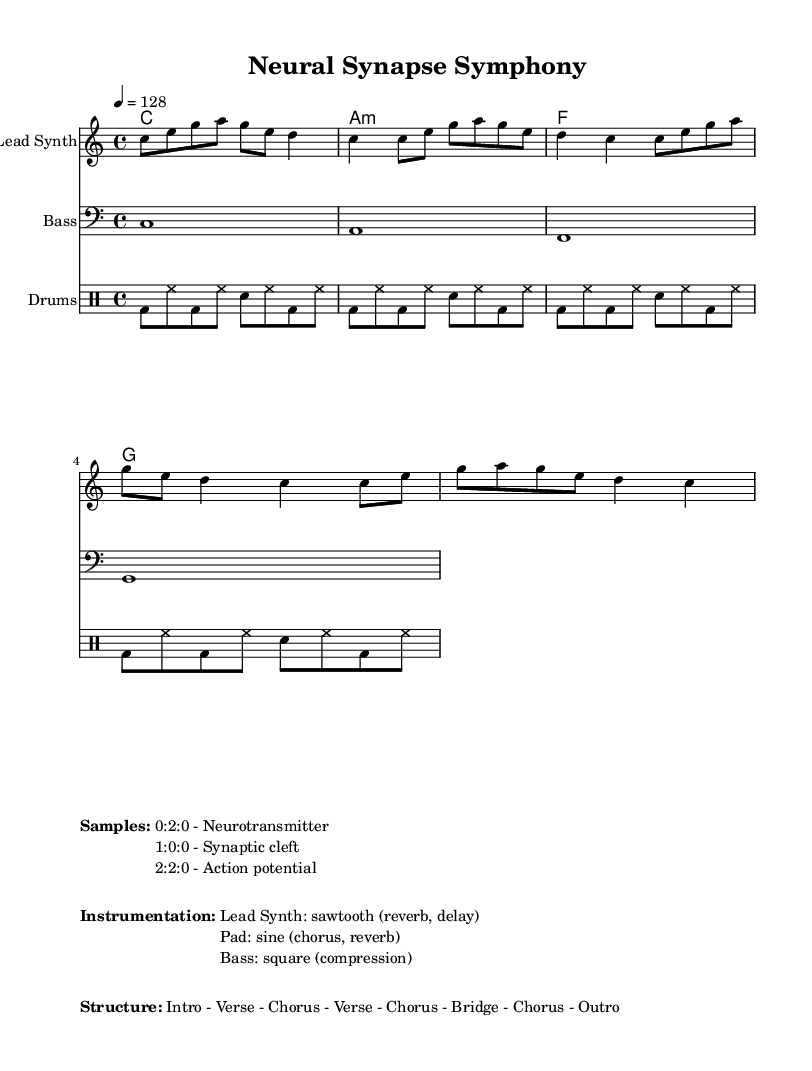What is the key signature of this music? The key signature is C major. In the sheet music, this is indicated by having no sharps or flats, as C major is the natural major scale starting on the note C.
Answer: C major What is the time signature of this music? The time signature is 4/4. It is found at the beginning of the music notated in the time signature section, indicating four beats per measure and the quarter note gets one beat.
Answer: 4/4 What is the tempo of this music? The tempo is 128 BPM (beats per minute). This is specified in the score where it indicates that the quarter note should be played at a speed of 128 beats per minute.
Answer: 128 How many measures are in the melody? The melody consists of 16 measures. By counting the vertical lines separating the parts of the melody in the sheet music, we can see that there are 16 complete measures shown.
Answer: 16 What instrument is labeled as "Lead Synth"? The instrument labeled "Lead Synth" corresponds to the melody staff in the score. The marking at the top of the staff specifies that it is the lead sound instrument, typically representing a prominent melodic line in electronic music.
Answer: Lead Synth Which audio samples are listed in the music sheet? The audio samples listed are "Neurotransmitter," "Synaptic cleft," and "Action potential." These are indicated in the markup section that describes the samples used within the composition, providing thematic relevance to the medical context.
Answer: Neurotransmitter, Synaptic cleft, Action potential What is the structure of this music? The structure is outlined as "Intro - Verse - Chorus - Verse - Chorus - Bridge - Chorus - Outro." This sequential labeling indicates the flow and form of the music, helping in understanding how the track is organized musically.
Answer: Intro - Verse - Chorus - Verse - Chorus - Bridge - Chorus - Outro 